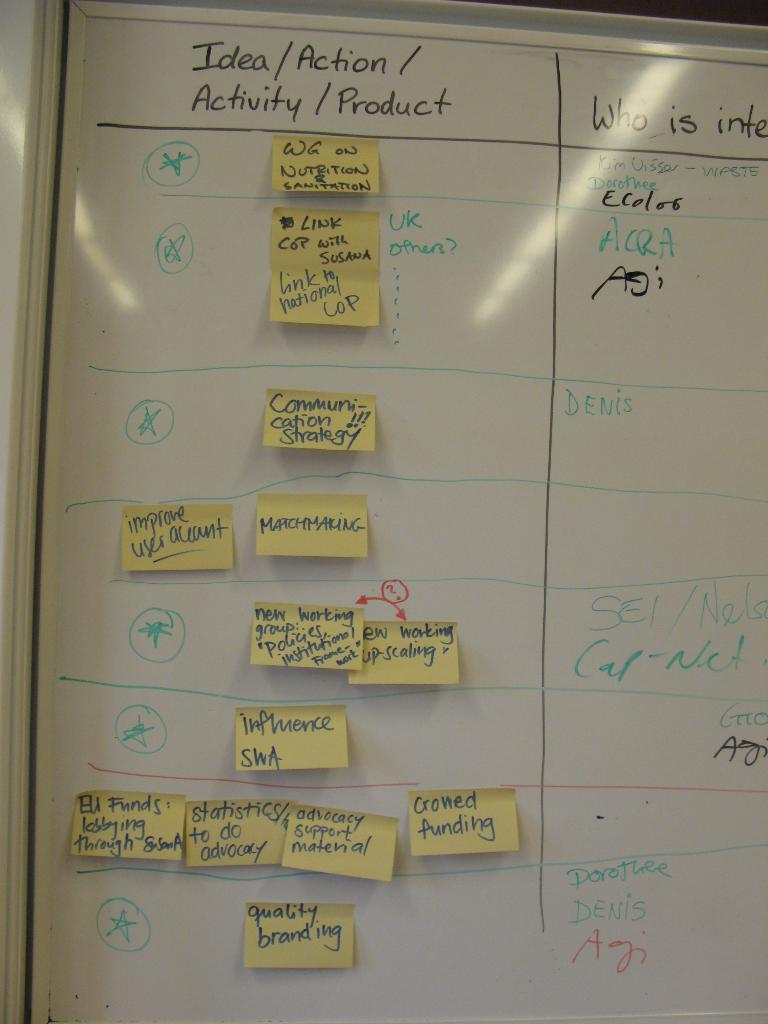<image>
Provide a brief description of the given image. Notes on a whiteboard about ideas, actions, activities, and products. 